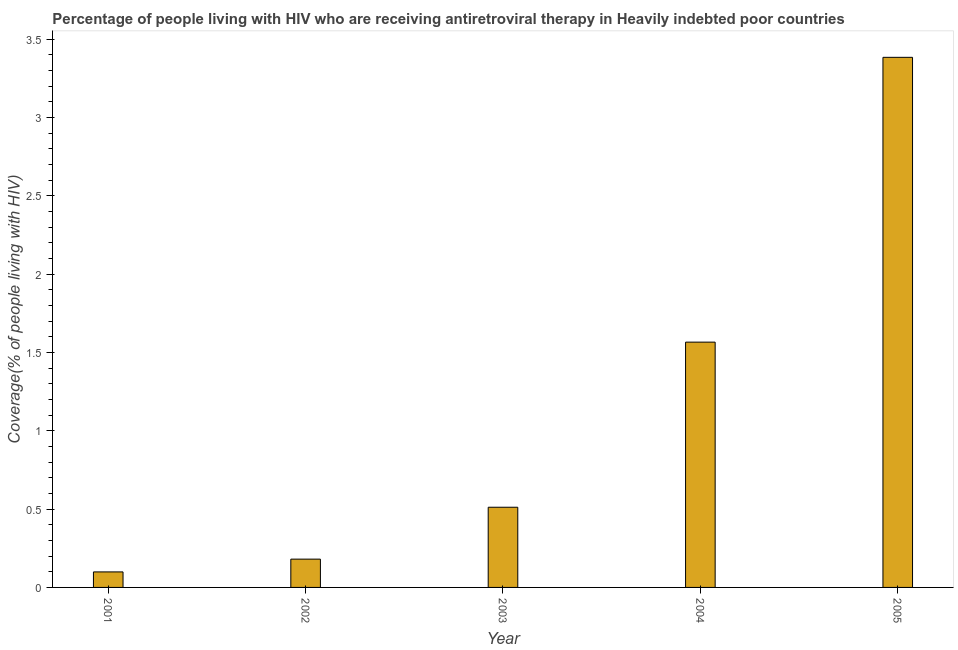Does the graph contain any zero values?
Keep it short and to the point. No. What is the title of the graph?
Your answer should be compact. Percentage of people living with HIV who are receiving antiretroviral therapy in Heavily indebted poor countries. What is the label or title of the X-axis?
Ensure brevity in your answer.  Year. What is the label or title of the Y-axis?
Give a very brief answer. Coverage(% of people living with HIV). What is the antiretroviral therapy coverage in 2004?
Offer a very short reply. 1.57. Across all years, what is the maximum antiretroviral therapy coverage?
Your response must be concise. 3.38. Across all years, what is the minimum antiretroviral therapy coverage?
Provide a short and direct response. 0.1. What is the sum of the antiretroviral therapy coverage?
Make the answer very short. 5.74. What is the difference between the antiretroviral therapy coverage in 2003 and 2005?
Provide a short and direct response. -2.87. What is the average antiretroviral therapy coverage per year?
Keep it short and to the point. 1.15. What is the median antiretroviral therapy coverage?
Your response must be concise. 0.51. Do a majority of the years between 2003 and 2004 (inclusive) have antiretroviral therapy coverage greater than 3.1 %?
Provide a succinct answer. No. What is the ratio of the antiretroviral therapy coverage in 2003 to that in 2004?
Offer a terse response. 0.33. What is the difference between the highest and the second highest antiretroviral therapy coverage?
Offer a terse response. 1.82. What is the difference between the highest and the lowest antiretroviral therapy coverage?
Your answer should be compact. 3.29. Are all the bars in the graph horizontal?
Offer a very short reply. No. What is the difference between two consecutive major ticks on the Y-axis?
Keep it short and to the point. 0.5. What is the Coverage(% of people living with HIV) in 2001?
Your answer should be very brief. 0.1. What is the Coverage(% of people living with HIV) in 2002?
Your response must be concise. 0.18. What is the Coverage(% of people living with HIV) in 2003?
Your response must be concise. 0.51. What is the Coverage(% of people living with HIV) in 2004?
Keep it short and to the point. 1.57. What is the Coverage(% of people living with HIV) of 2005?
Offer a terse response. 3.38. What is the difference between the Coverage(% of people living with HIV) in 2001 and 2002?
Ensure brevity in your answer.  -0.08. What is the difference between the Coverage(% of people living with HIV) in 2001 and 2003?
Provide a short and direct response. -0.41. What is the difference between the Coverage(% of people living with HIV) in 2001 and 2004?
Your answer should be compact. -1.47. What is the difference between the Coverage(% of people living with HIV) in 2001 and 2005?
Your response must be concise. -3.29. What is the difference between the Coverage(% of people living with HIV) in 2002 and 2003?
Offer a very short reply. -0.33. What is the difference between the Coverage(% of people living with HIV) in 2002 and 2004?
Ensure brevity in your answer.  -1.39. What is the difference between the Coverage(% of people living with HIV) in 2002 and 2005?
Your answer should be compact. -3.2. What is the difference between the Coverage(% of people living with HIV) in 2003 and 2004?
Your response must be concise. -1.05. What is the difference between the Coverage(% of people living with HIV) in 2003 and 2005?
Your response must be concise. -2.87. What is the difference between the Coverage(% of people living with HIV) in 2004 and 2005?
Give a very brief answer. -1.82. What is the ratio of the Coverage(% of people living with HIV) in 2001 to that in 2002?
Your answer should be compact. 0.55. What is the ratio of the Coverage(% of people living with HIV) in 2001 to that in 2003?
Make the answer very short. 0.19. What is the ratio of the Coverage(% of people living with HIV) in 2001 to that in 2004?
Your answer should be compact. 0.06. What is the ratio of the Coverage(% of people living with HIV) in 2001 to that in 2005?
Ensure brevity in your answer.  0.03. What is the ratio of the Coverage(% of people living with HIV) in 2002 to that in 2003?
Provide a short and direct response. 0.35. What is the ratio of the Coverage(% of people living with HIV) in 2002 to that in 2004?
Provide a succinct answer. 0.12. What is the ratio of the Coverage(% of people living with HIV) in 2002 to that in 2005?
Provide a short and direct response. 0.05. What is the ratio of the Coverage(% of people living with HIV) in 2003 to that in 2004?
Your response must be concise. 0.33. What is the ratio of the Coverage(% of people living with HIV) in 2003 to that in 2005?
Provide a short and direct response. 0.15. What is the ratio of the Coverage(% of people living with HIV) in 2004 to that in 2005?
Your answer should be compact. 0.46. 